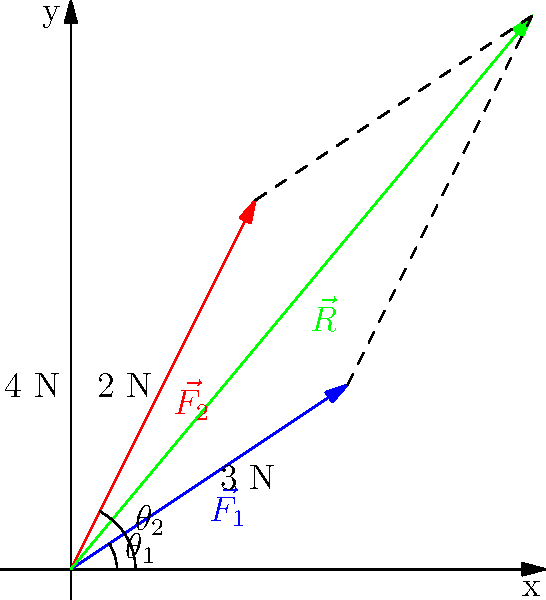As a developer working on a physics simulation for your blog, you need to calculate the resultant vector when combining two force vectors. Given $\vec{F_1} = 3\hat{i} + 2\hat{j}$ N and $\vec{F_2} = 2\hat{i} + 4\hat{j}$ N, what is the magnitude of the resultant force vector $\vec{R}$ to the nearest tenth of a Newton? To solve this problem, we'll follow these steps:

1) First, we need to add the two force vectors to get the resultant vector:
   $\vec{R} = \vec{F_1} + \vec{F_2}$
   $\vec{R} = (3\hat{i} + 2\hat{j}) + (2\hat{i} + 4\hat{j})$
   $\vec{R} = 5\hat{i} + 6\hat{j}$

2) Now that we have the components of the resultant vector, we can calculate its magnitude using the Pythagorean theorem:
   $|\vec{R}| = \sqrt{R_x^2 + R_y^2}$

3) Substituting the values:
   $|\vec{R}| = \sqrt{5^2 + 6^2}$

4) Simplify:
   $|\vec{R}| = \sqrt{25 + 36}$
   $|\vec{R}| = \sqrt{61}$

5) Calculate and round to the nearest tenth:
   $|\vec{R}| \approx 7.8$ N

This method of vector addition is crucial in many physics simulations and can be implemented efficiently in code using vector operations.
Answer: 7.8 N 